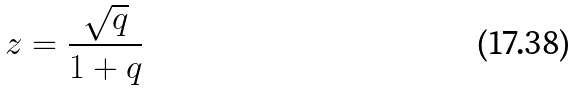<formula> <loc_0><loc_0><loc_500><loc_500>z = \frac { \sqrt { q } } { 1 + q }</formula> 